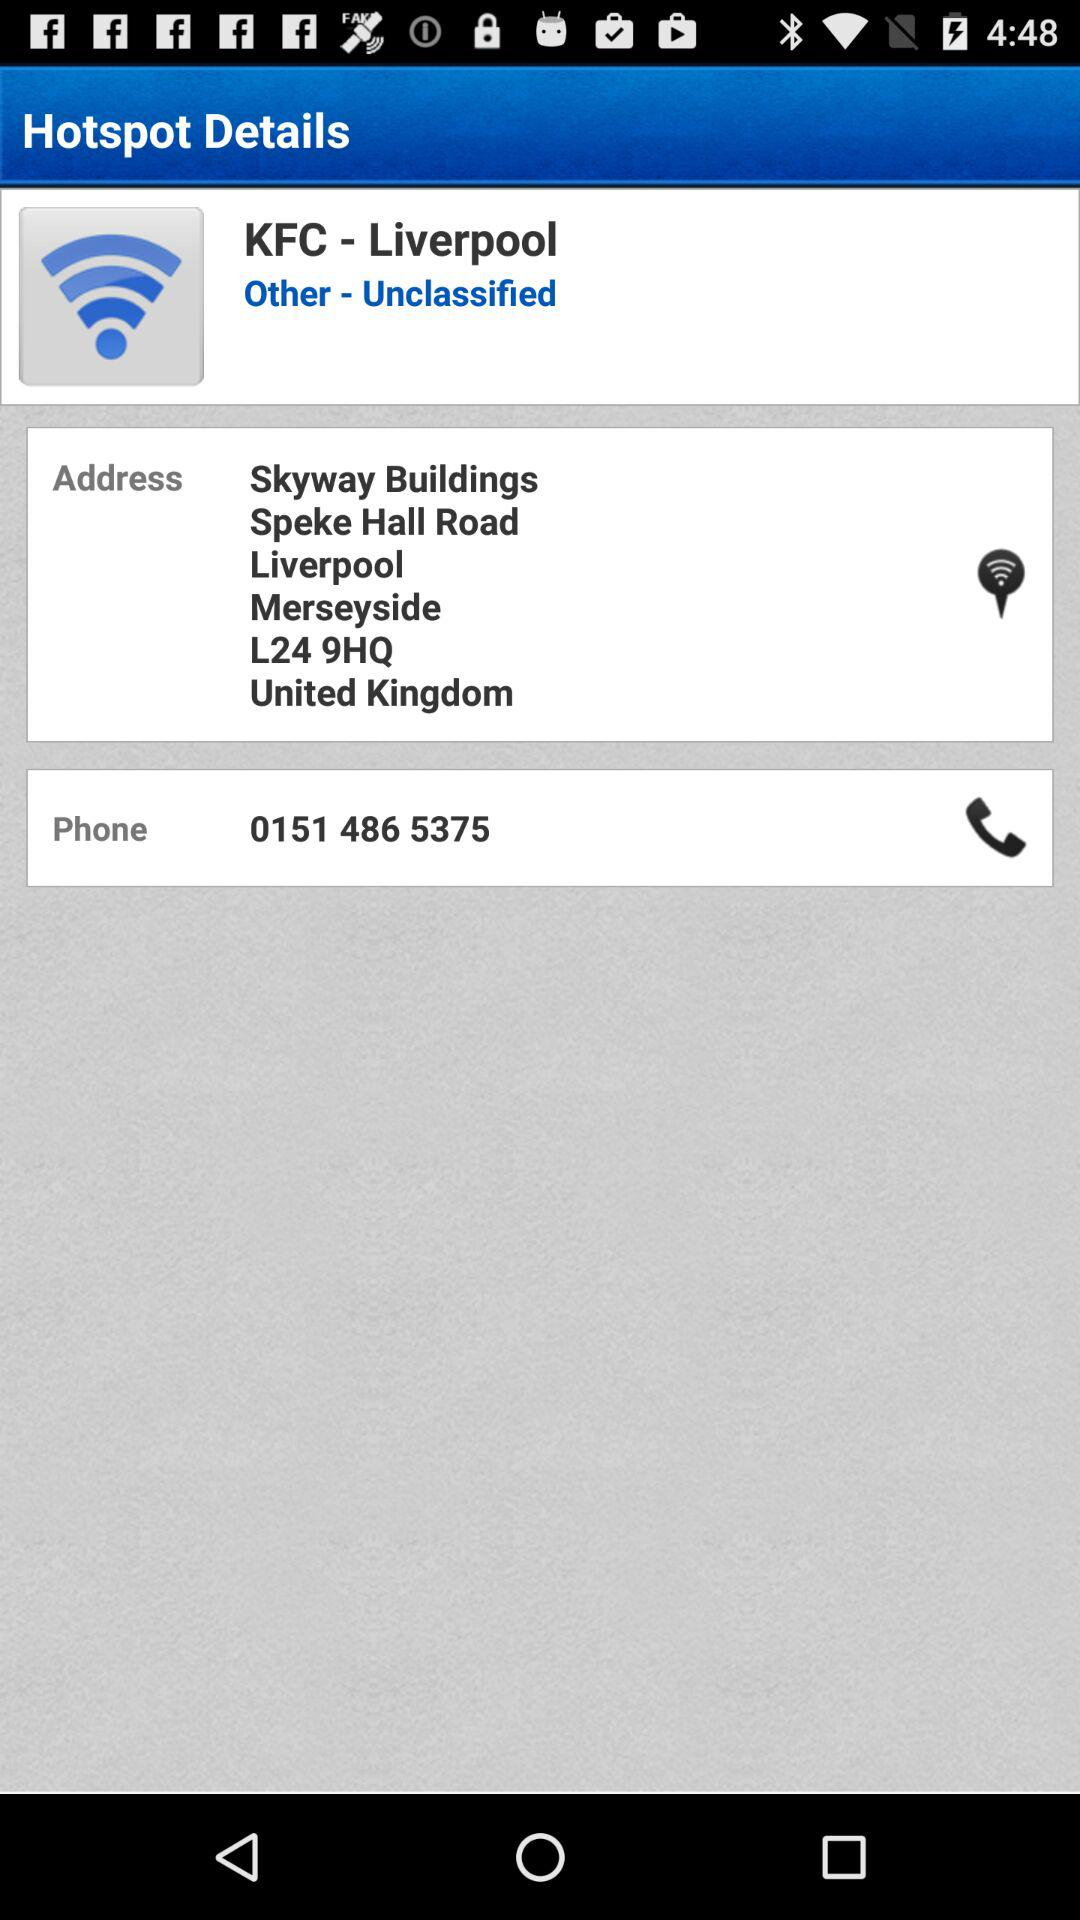What is the address? The address is Skyway Buildings, Speke Hall Road, Liverpool, Merseyside, L24 9HQ, United Kingdom. 